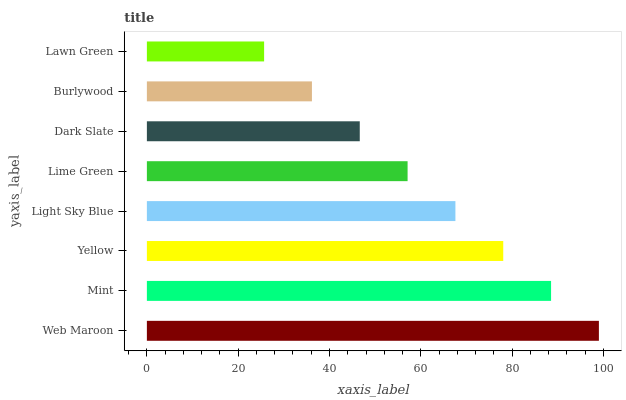Is Lawn Green the minimum?
Answer yes or no. Yes. Is Web Maroon the maximum?
Answer yes or no. Yes. Is Mint the minimum?
Answer yes or no. No. Is Mint the maximum?
Answer yes or no. No. Is Web Maroon greater than Mint?
Answer yes or no. Yes. Is Mint less than Web Maroon?
Answer yes or no. Yes. Is Mint greater than Web Maroon?
Answer yes or no. No. Is Web Maroon less than Mint?
Answer yes or no. No. Is Light Sky Blue the high median?
Answer yes or no. Yes. Is Lime Green the low median?
Answer yes or no. Yes. Is Lawn Green the high median?
Answer yes or no. No. Is Burlywood the low median?
Answer yes or no. No. 